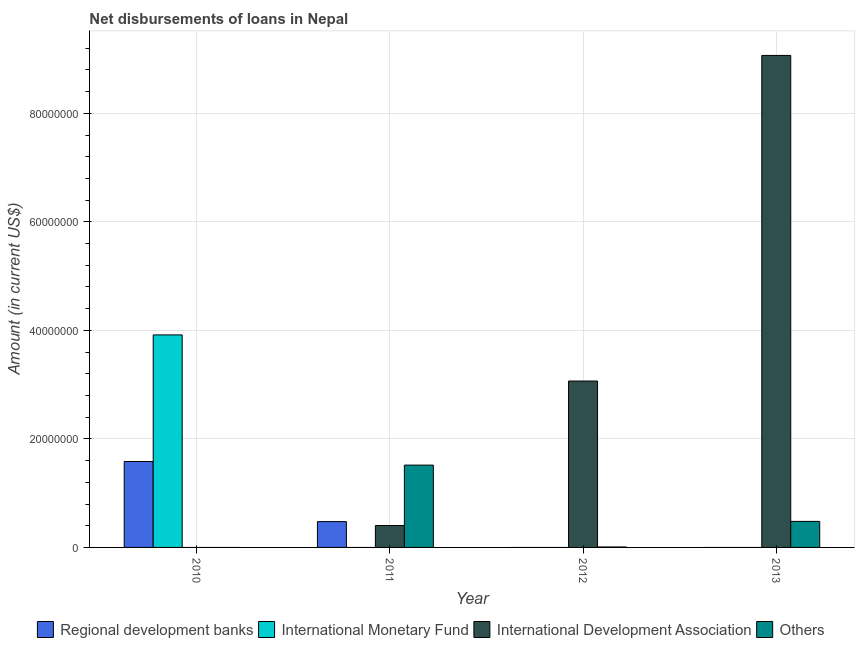How many groups of bars are there?
Provide a short and direct response. 4. Are the number of bars per tick equal to the number of legend labels?
Offer a very short reply. No. Are the number of bars on each tick of the X-axis equal?
Ensure brevity in your answer.  No. How many bars are there on the 1st tick from the right?
Give a very brief answer. 2. In how many cases, is the number of bars for a given year not equal to the number of legend labels?
Your answer should be very brief. 4. What is the amount of loan disimbursed by international development association in 2011?
Your answer should be compact. 4.04e+06. Across all years, what is the maximum amount of loan disimbursed by other organisations?
Your answer should be compact. 1.52e+07. In which year was the amount of loan disimbursed by international monetary fund maximum?
Keep it short and to the point. 2010. What is the total amount of loan disimbursed by other organisations in the graph?
Provide a short and direct response. 2.01e+07. What is the difference between the amount of loan disimbursed by international development association in 2012 and that in 2013?
Make the answer very short. -6.00e+07. What is the difference between the amount of loan disimbursed by regional development banks in 2013 and the amount of loan disimbursed by international development association in 2011?
Give a very brief answer. -4.76e+06. What is the average amount of loan disimbursed by regional development banks per year?
Your answer should be very brief. 5.15e+06. In the year 2011, what is the difference between the amount of loan disimbursed by other organisations and amount of loan disimbursed by regional development banks?
Offer a very short reply. 0. What is the ratio of the amount of loan disimbursed by other organisations in 2011 to that in 2013?
Offer a terse response. 3.16. Is the amount of loan disimbursed by other organisations in 2011 less than that in 2012?
Your answer should be compact. No. What is the difference between the highest and the second highest amount of loan disimbursed by other organisations?
Provide a succinct answer. 1.04e+07. What is the difference between the highest and the lowest amount of loan disimbursed by international monetary fund?
Your answer should be compact. 3.92e+07. Are all the bars in the graph horizontal?
Ensure brevity in your answer.  No. Does the graph contain any zero values?
Offer a very short reply. Yes. Where does the legend appear in the graph?
Offer a very short reply. Bottom center. How are the legend labels stacked?
Your response must be concise. Horizontal. What is the title of the graph?
Make the answer very short. Net disbursements of loans in Nepal. What is the label or title of the X-axis?
Your answer should be very brief. Year. What is the label or title of the Y-axis?
Your response must be concise. Amount (in current US$). What is the Amount (in current US$) in Regional development banks in 2010?
Your answer should be compact. 1.58e+07. What is the Amount (in current US$) of International Monetary Fund in 2010?
Offer a terse response. 3.92e+07. What is the Amount (in current US$) in International Development Association in 2010?
Your answer should be compact. 0. What is the Amount (in current US$) in Others in 2010?
Make the answer very short. 0. What is the Amount (in current US$) of Regional development banks in 2011?
Ensure brevity in your answer.  4.76e+06. What is the Amount (in current US$) in International Development Association in 2011?
Your answer should be very brief. 4.04e+06. What is the Amount (in current US$) in Others in 2011?
Offer a very short reply. 1.52e+07. What is the Amount (in current US$) of Regional development banks in 2012?
Keep it short and to the point. 0. What is the Amount (in current US$) of International Monetary Fund in 2012?
Your response must be concise. 0. What is the Amount (in current US$) of International Development Association in 2012?
Provide a short and direct response. 3.07e+07. What is the Amount (in current US$) in Others in 2012?
Offer a very short reply. 8.40e+04. What is the Amount (in current US$) in International Development Association in 2013?
Your response must be concise. 9.07e+07. What is the Amount (in current US$) of Others in 2013?
Provide a succinct answer. 4.80e+06. Across all years, what is the maximum Amount (in current US$) in Regional development banks?
Offer a very short reply. 1.58e+07. Across all years, what is the maximum Amount (in current US$) in International Monetary Fund?
Provide a succinct answer. 3.92e+07. Across all years, what is the maximum Amount (in current US$) of International Development Association?
Your answer should be very brief. 9.07e+07. Across all years, what is the maximum Amount (in current US$) in Others?
Keep it short and to the point. 1.52e+07. Across all years, what is the minimum Amount (in current US$) of Regional development banks?
Offer a very short reply. 0. Across all years, what is the minimum Amount (in current US$) in International Monetary Fund?
Your answer should be very brief. 0. What is the total Amount (in current US$) of Regional development banks in the graph?
Offer a terse response. 2.06e+07. What is the total Amount (in current US$) in International Monetary Fund in the graph?
Ensure brevity in your answer.  3.92e+07. What is the total Amount (in current US$) of International Development Association in the graph?
Give a very brief answer. 1.25e+08. What is the total Amount (in current US$) of Others in the graph?
Offer a very short reply. 2.01e+07. What is the difference between the Amount (in current US$) of Regional development banks in 2010 and that in 2011?
Offer a terse response. 1.11e+07. What is the difference between the Amount (in current US$) in International Development Association in 2011 and that in 2012?
Provide a succinct answer. -2.66e+07. What is the difference between the Amount (in current US$) in Others in 2011 and that in 2012?
Provide a short and direct response. 1.51e+07. What is the difference between the Amount (in current US$) in International Development Association in 2011 and that in 2013?
Provide a short and direct response. -8.66e+07. What is the difference between the Amount (in current US$) in Others in 2011 and that in 2013?
Your answer should be very brief. 1.04e+07. What is the difference between the Amount (in current US$) in International Development Association in 2012 and that in 2013?
Your answer should be compact. -6.00e+07. What is the difference between the Amount (in current US$) of Others in 2012 and that in 2013?
Your answer should be compact. -4.72e+06. What is the difference between the Amount (in current US$) of Regional development banks in 2010 and the Amount (in current US$) of International Development Association in 2011?
Ensure brevity in your answer.  1.18e+07. What is the difference between the Amount (in current US$) in Regional development banks in 2010 and the Amount (in current US$) in Others in 2011?
Keep it short and to the point. 6.63e+05. What is the difference between the Amount (in current US$) in International Monetary Fund in 2010 and the Amount (in current US$) in International Development Association in 2011?
Keep it short and to the point. 3.51e+07. What is the difference between the Amount (in current US$) of International Monetary Fund in 2010 and the Amount (in current US$) of Others in 2011?
Make the answer very short. 2.40e+07. What is the difference between the Amount (in current US$) of Regional development banks in 2010 and the Amount (in current US$) of International Development Association in 2012?
Your answer should be compact. -1.48e+07. What is the difference between the Amount (in current US$) of Regional development banks in 2010 and the Amount (in current US$) of Others in 2012?
Give a very brief answer. 1.58e+07. What is the difference between the Amount (in current US$) of International Monetary Fund in 2010 and the Amount (in current US$) of International Development Association in 2012?
Offer a very short reply. 8.50e+06. What is the difference between the Amount (in current US$) of International Monetary Fund in 2010 and the Amount (in current US$) of Others in 2012?
Your answer should be very brief. 3.91e+07. What is the difference between the Amount (in current US$) of Regional development banks in 2010 and the Amount (in current US$) of International Development Association in 2013?
Ensure brevity in your answer.  -7.48e+07. What is the difference between the Amount (in current US$) in Regional development banks in 2010 and the Amount (in current US$) in Others in 2013?
Ensure brevity in your answer.  1.10e+07. What is the difference between the Amount (in current US$) of International Monetary Fund in 2010 and the Amount (in current US$) of International Development Association in 2013?
Ensure brevity in your answer.  -5.15e+07. What is the difference between the Amount (in current US$) in International Monetary Fund in 2010 and the Amount (in current US$) in Others in 2013?
Ensure brevity in your answer.  3.44e+07. What is the difference between the Amount (in current US$) of Regional development banks in 2011 and the Amount (in current US$) of International Development Association in 2012?
Offer a very short reply. -2.59e+07. What is the difference between the Amount (in current US$) of Regional development banks in 2011 and the Amount (in current US$) of Others in 2012?
Make the answer very short. 4.67e+06. What is the difference between the Amount (in current US$) of International Development Association in 2011 and the Amount (in current US$) of Others in 2012?
Keep it short and to the point. 3.95e+06. What is the difference between the Amount (in current US$) of Regional development banks in 2011 and the Amount (in current US$) of International Development Association in 2013?
Your answer should be very brief. -8.59e+07. What is the difference between the Amount (in current US$) of Regional development banks in 2011 and the Amount (in current US$) of Others in 2013?
Keep it short and to the point. -4.10e+04. What is the difference between the Amount (in current US$) of International Development Association in 2011 and the Amount (in current US$) of Others in 2013?
Offer a very short reply. -7.61e+05. What is the difference between the Amount (in current US$) in International Development Association in 2012 and the Amount (in current US$) in Others in 2013?
Make the answer very short. 2.59e+07. What is the average Amount (in current US$) in Regional development banks per year?
Provide a succinct answer. 5.15e+06. What is the average Amount (in current US$) in International Monetary Fund per year?
Ensure brevity in your answer.  9.79e+06. What is the average Amount (in current US$) in International Development Association per year?
Your answer should be compact. 3.13e+07. What is the average Amount (in current US$) in Others per year?
Offer a terse response. 5.01e+06. In the year 2010, what is the difference between the Amount (in current US$) in Regional development banks and Amount (in current US$) in International Monetary Fund?
Your answer should be compact. -2.33e+07. In the year 2011, what is the difference between the Amount (in current US$) of Regional development banks and Amount (in current US$) of International Development Association?
Ensure brevity in your answer.  7.20e+05. In the year 2011, what is the difference between the Amount (in current US$) in Regional development banks and Amount (in current US$) in Others?
Make the answer very short. -1.04e+07. In the year 2011, what is the difference between the Amount (in current US$) of International Development Association and Amount (in current US$) of Others?
Provide a succinct answer. -1.11e+07. In the year 2012, what is the difference between the Amount (in current US$) in International Development Association and Amount (in current US$) in Others?
Provide a succinct answer. 3.06e+07. In the year 2013, what is the difference between the Amount (in current US$) in International Development Association and Amount (in current US$) in Others?
Provide a succinct answer. 8.59e+07. What is the ratio of the Amount (in current US$) of Regional development banks in 2010 to that in 2011?
Make the answer very short. 3.33. What is the ratio of the Amount (in current US$) in International Development Association in 2011 to that in 2012?
Your answer should be very brief. 0.13. What is the ratio of the Amount (in current US$) of Others in 2011 to that in 2012?
Keep it short and to the point. 180.63. What is the ratio of the Amount (in current US$) of International Development Association in 2011 to that in 2013?
Your answer should be very brief. 0.04. What is the ratio of the Amount (in current US$) of Others in 2011 to that in 2013?
Your response must be concise. 3.16. What is the ratio of the Amount (in current US$) in International Development Association in 2012 to that in 2013?
Provide a short and direct response. 0.34. What is the ratio of the Amount (in current US$) in Others in 2012 to that in 2013?
Keep it short and to the point. 0.02. What is the difference between the highest and the second highest Amount (in current US$) in International Development Association?
Your response must be concise. 6.00e+07. What is the difference between the highest and the second highest Amount (in current US$) of Others?
Ensure brevity in your answer.  1.04e+07. What is the difference between the highest and the lowest Amount (in current US$) in Regional development banks?
Give a very brief answer. 1.58e+07. What is the difference between the highest and the lowest Amount (in current US$) in International Monetary Fund?
Make the answer very short. 3.92e+07. What is the difference between the highest and the lowest Amount (in current US$) of International Development Association?
Give a very brief answer. 9.07e+07. What is the difference between the highest and the lowest Amount (in current US$) of Others?
Keep it short and to the point. 1.52e+07. 